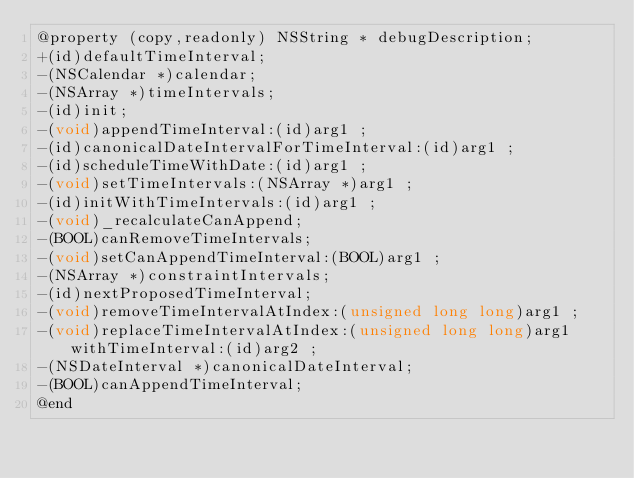Convert code to text. <code><loc_0><loc_0><loc_500><loc_500><_C_>@property (copy,readonly) NSString * debugDescription; 
+(id)defaultTimeInterval;
-(NSCalendar *)calendar;
-(NSArray *)timeIntervals;
-(id)init;
-(void)appendTimeInterval:(id)arg1 ;
-(id)canonicalDateIntervalForTimeInterval:(id)arg1 ;
-(id)scheduleTimeWithDate:(id)arg1 ;
-(void)setTimeIntervals:(NSArray *)arg1 ;
-(id)initWithTimeIntervals:(id)arg1 ;
-(void)_recalculateCanAppend;
-(BOOL)canRemoveTimeIntervals;
-(void)setCanAppendTimeInterval:(BOOL)arg1 ;
-(NSArray *)constraintIntervals;
-(id)nextProposedTimeInterval;
-(void)removeTimeIntervalAtIndex:(unsigned long long)arg1 ;
-(void)replaceTimeIntervalAtIndex:(unsigned long long)arg1 withTimeInterval:(id)arg2 ;
-(NSDateInterval *)canonicalDateInterval;
-(BOOL)canAppendTimeInterval;
@end

</code> 